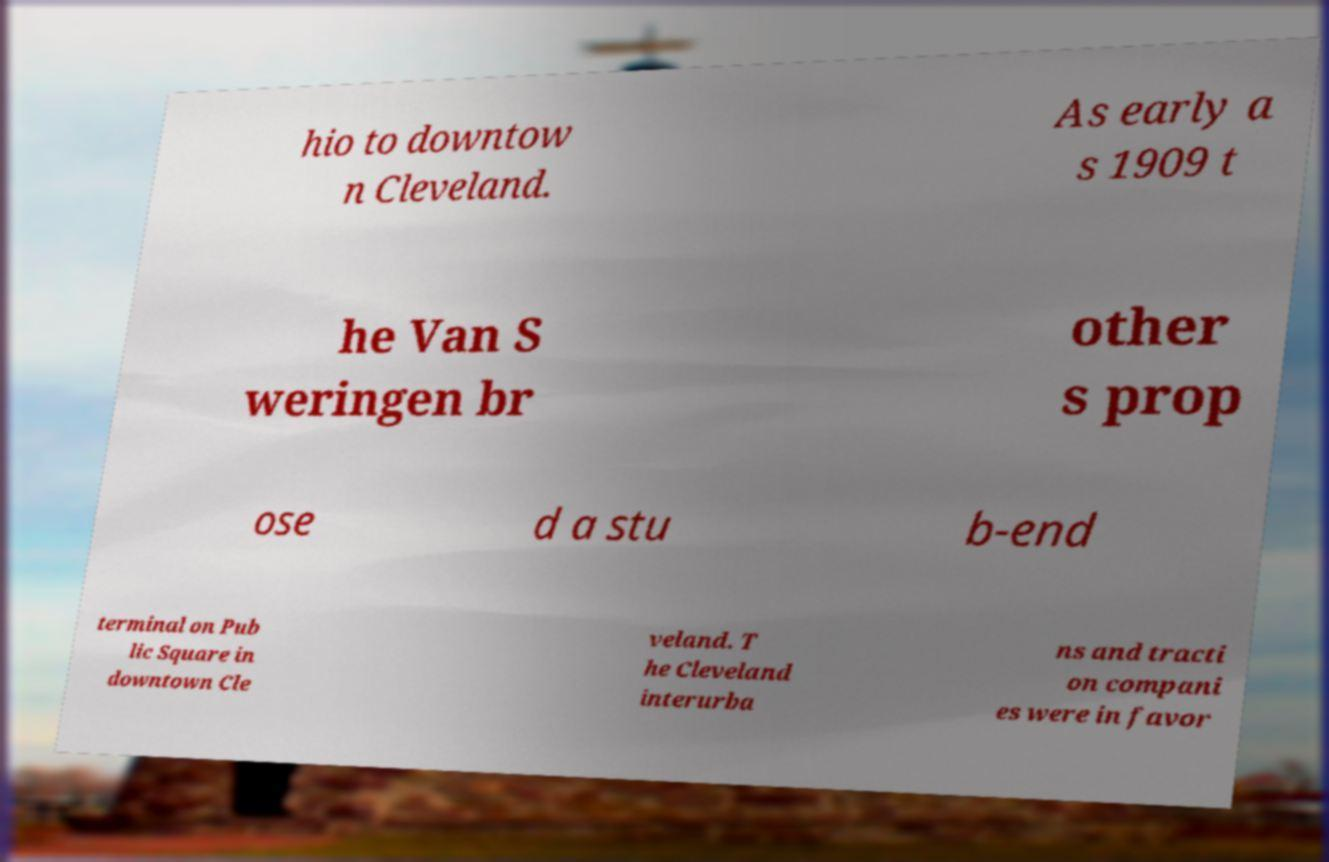Could you assist in decoding the text presented in this image and type it out clearly? hio to downtow n Cleveland. As early a s 1909 t he Van S weringen br other s prop ose d a stu b-end terminal on Pub lic Square in downtown Cle veland. T he Cleveland interurba ns and tracti on compani es were in favor 